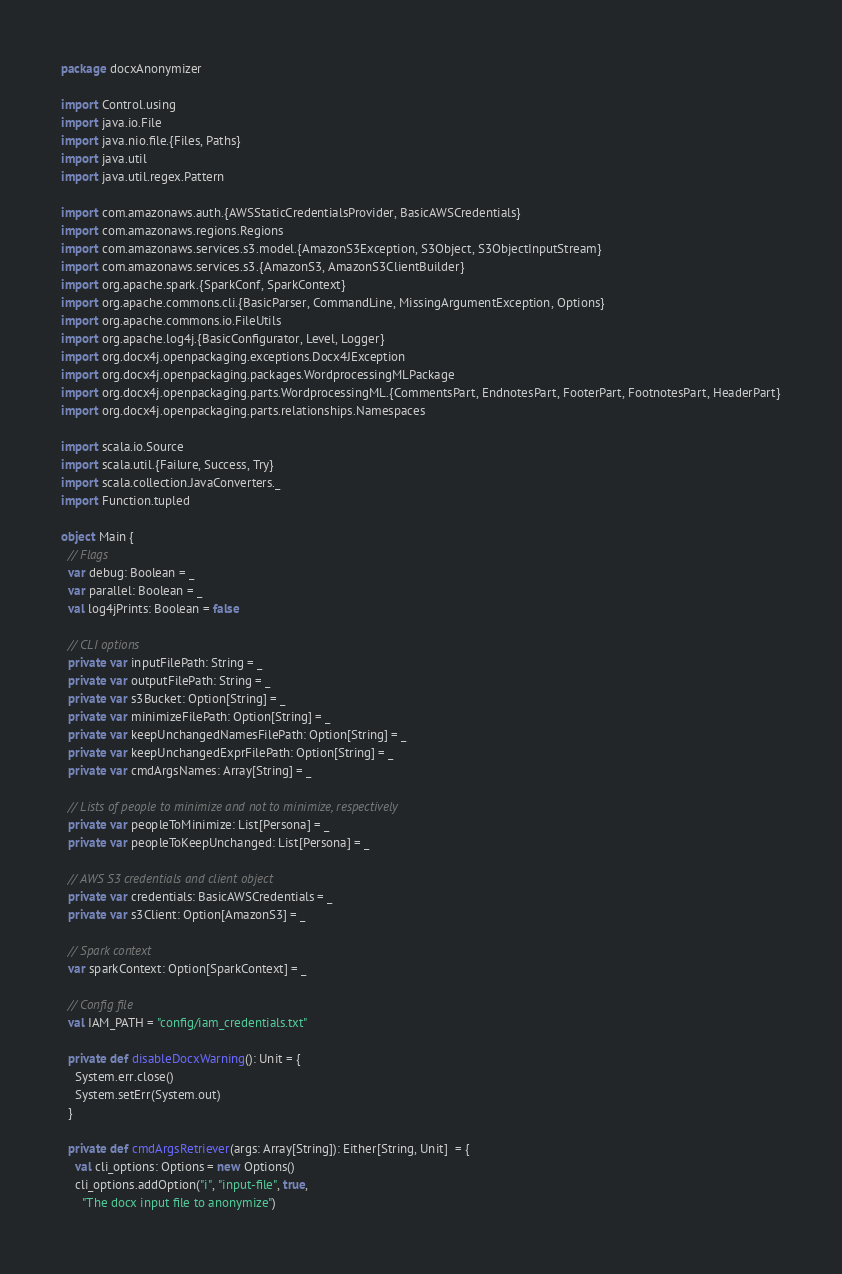<code> <loc_0><loc_0><loc_500><loc_500><_Scala_>package docxAnonymizer

import Control.using
import java.io.File
import java.nio.file.{Files, Paths}
import java.util
import java.util.regex.Pattern

import com.amazonaws.auth.{AWSStaticCredentialsProvider, BasicAWSCredentials}
import com.amazonaws.regions.Regions
import com.amazonaws.services.s3.model.{AmazonS3Exception, S3Object, S3ObjectInputStream}
import com.amazonaws.services.s3.{AmazonS3, AmazonS3ClientBuilder}
import org.apache.spark.{SparkConf, SparkContext}
import org.apache.commons.cli.{BasicParser, CommandLine, MissingArgumentException, Options}
import org.apache.commons.io.FileUtils
import org.apache.log4j.{BasicConfigurator, Level, Logger}
import org.docx4j.openpackaging.exceptions.Docx4JException
import org.docx4j.openpackaging.packages.WordprocessingMLPackage
import org.docx4j.openpackaging.parts.WordprocessingML.{CommentsPart, EndnotesPart, FooterPart, FootnotesPart, HeaderPart}
import org.docx4j.openpackaging.parts.relationships.Namespaces

import scala.io.Source
import scala.util.{Failure, Success, Try}
import scala.collection.JavaConverters._
import Function.tupled

object Main {
  // Flags
  var debug: Boolean = _
  var parallel: Boolean = _
  val log4jPrints: Boolean = false

  // CLI options
  private var inputFilePath: String = _
  private var outputFilePath: String = _
  private var s3Bucket: Option[String] = _
  private var minimizeFilePath: Option[String] = _
  private var keepUnchangedNamesFilePath: Option[String] = _
  private var keepUnchangedExprFilePath: Option[String] = _
  private var cmdArgsNames: Array[String] = _

  // Lists of people to minimize and not to minimize, respectively
  private var peopleToMinimize: List[Persona] = _
  private var peopleToKeepUnchanged: List[Persona] = _

  // AWS S3 credentials and client object
  private var credentials: BasicAWSCredentials = _
  private var s3Client: Option[AmazonS3] = _

  // Spark context
  var sparkContext: Option[SparkContext] = _

  // Config file
  val IAM_PATH = "config/iam_credentials.txt"

  private def disableDocxWarning(): Unit = {
    System.err.close()
    System.setErr(System.out)
  }

  private def cmdArgsRetriever(args: Array[String]): Either[String, Unit]  = {
    val cli_options: Options = new Options()
    cli_options.addOption("i", "input-file", true,
      "The docx input file to anonymize")</code> 